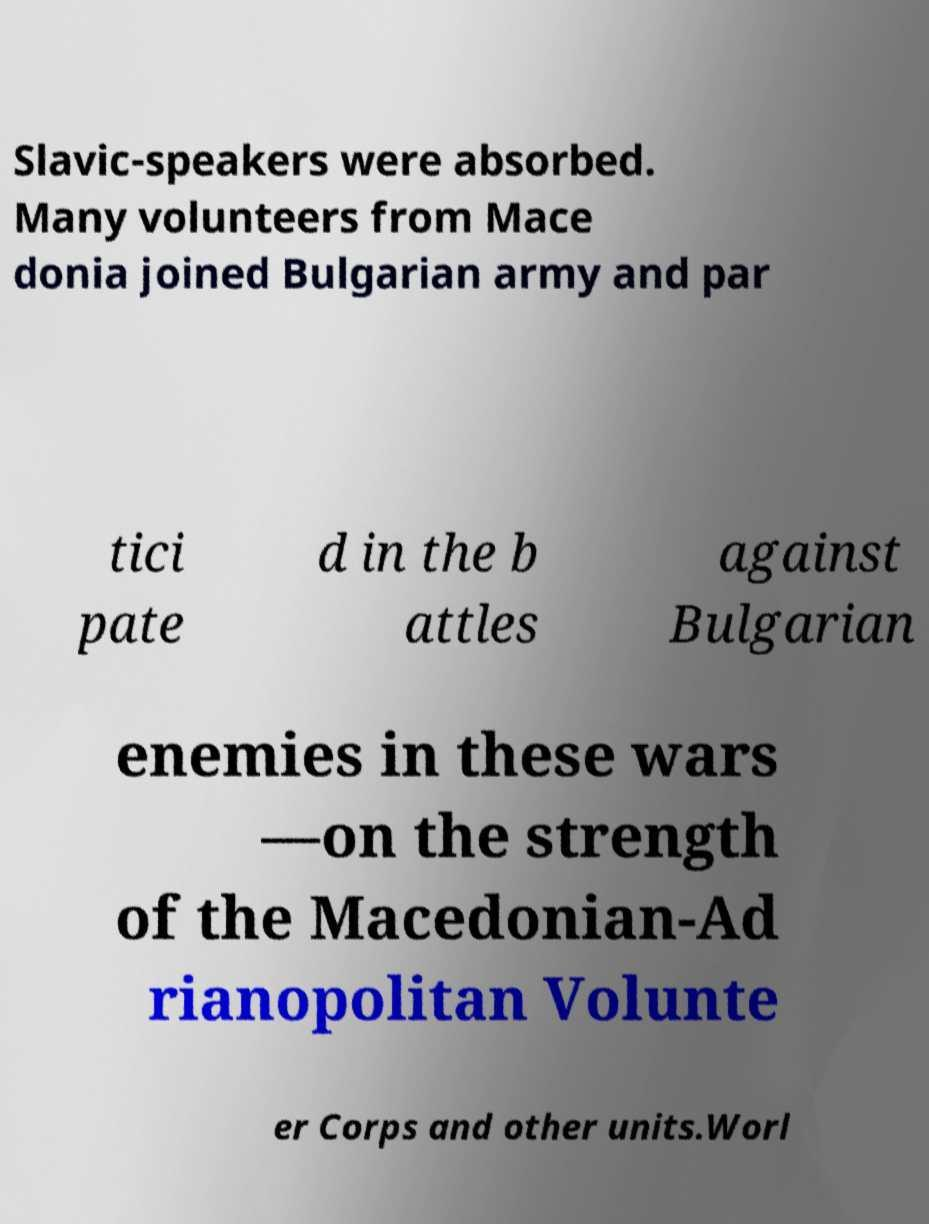What messages or text are displayed in this image? I need them in a readable, typed format. Slavic-speakers were absorbed. Many volunteers from Mace donia joined Bulgarian army and par tici pate d in the b attles against Bulgarian enemies in these wars —on the strength of the Macedonian-Ad rianopolitan Volunte er Corps and other units.Worl 